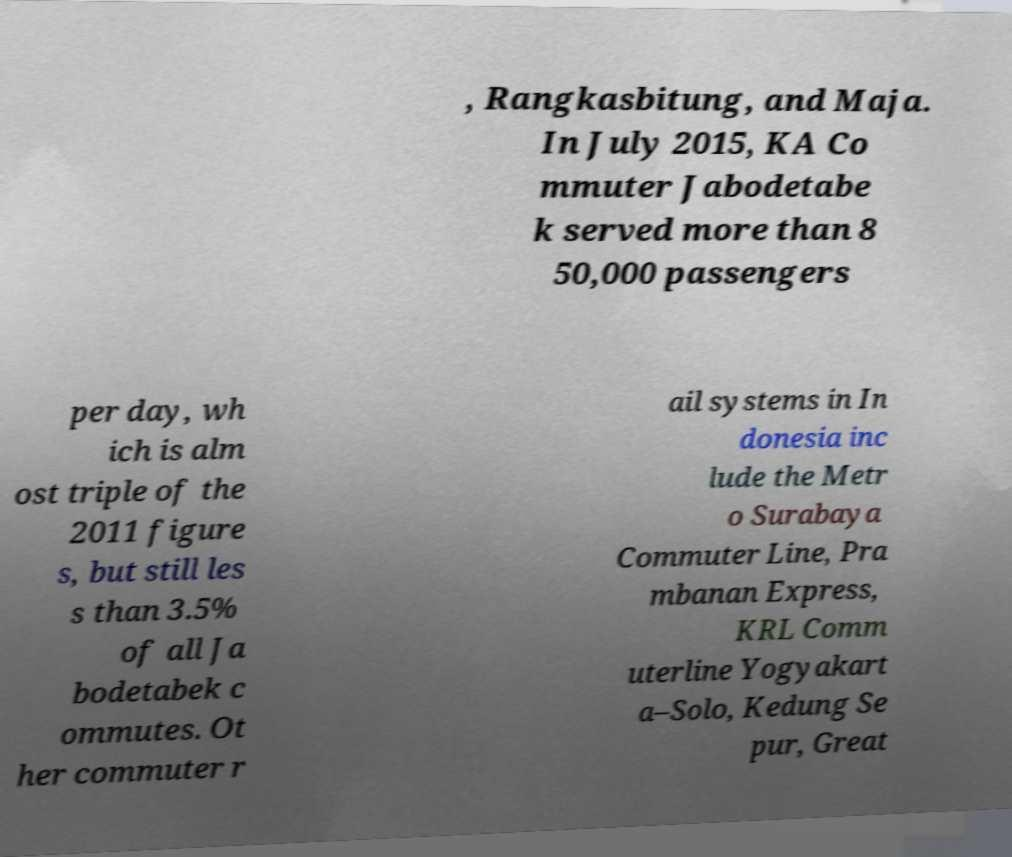For documentation purposes, I need the text within this image transcribed. Could you provide that? , Rangkasbitung, and Maja. In July 2015, KA Co mmuter Jabodetabe k served more than 8 50,000 passengers per day, wh ich is alm ost triple of the 2011 figure s, but still les s than 3.5% of all Ja bodetabek c ommutes. Ot her commuter r ail systems in In donesia inc lude the Metr o Surabaya Commuter Line, Pra mbanan Express, KRL Comm uterline Yogyakart a–Solo, Kedung Se pur, Great 